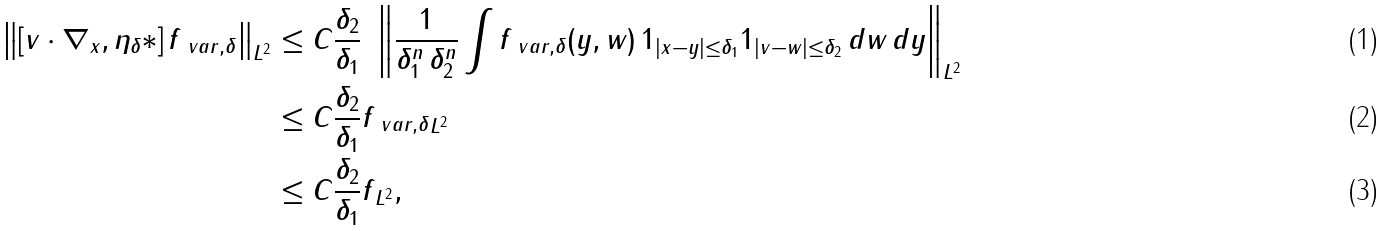Convert formula to latex. <formula><loc_0><loc_0><loc_500><loc_500>\left \| [ v \cdot \nabla _ { x } , \eta _ { \delta } \ast ] \, f _ { \ v a r , \delta } \right \| _ { L ^ { 2 } } & \leq C \frac { \delta _ { 2 } } { \delta _ { 1 } } \ \left \| \frac { 1 } { \delta _ { 1 } ^ { n } \, \delta _ { 2 } ^ { n } } \int f _ { \ v a r , \delta } ( y , w ) \, 1 _ { | x - y | \leq \delta _ { 1 } } 1 _ { | v - w | \leq \delta _ { 2 } } \, d w \, d y \right \| _ { L ^ { 2 } } \\ & \leq C \frac { \delta _ { 2 } } { \delta _ { 1 } } \| f _ { \ v a r , \delta } \| _ { L ^ { 2 } } \\ & \leq C \frac { \delta _ { 2 } } { \delta _ { 1 } } \| f \| _ { L ^ { 2 } } ,</formula> 